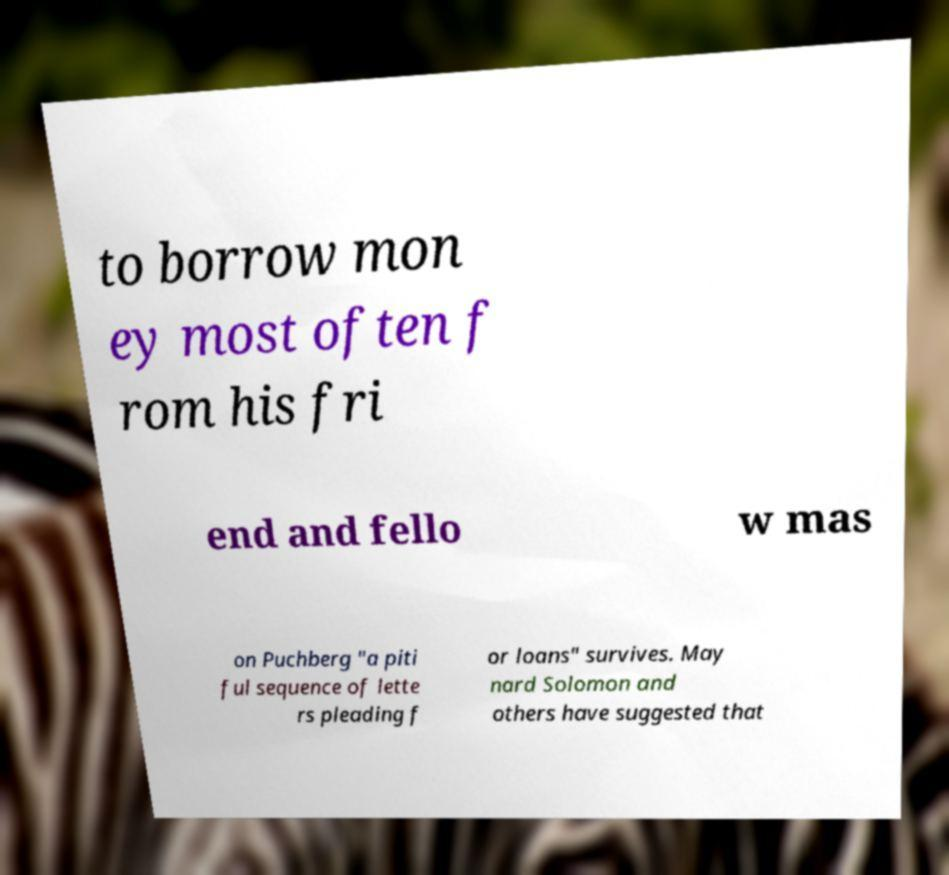Could you extract and type out the text from this image? to borrow mon ey most often f rom his fri end and fello w mas on Puchberg "a piti ful sequence of lette rs pleading f or loans" survives. May nard Solomon and others have suggested that 